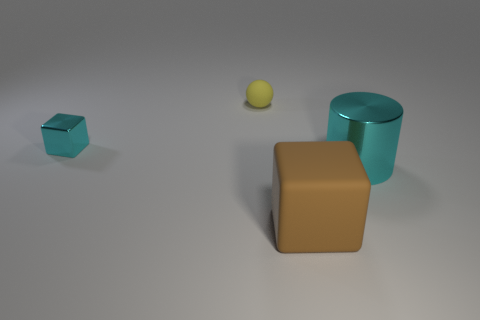The cyan metal thing that is the same size as the matte ball is what shape?
Keep it short and to the point. Cube. There is a small shiny thing; is its color the same as the tiny thing right of the small cyan metallic cube?
Offer a very short reply. No. How many things are either cyan metallic objects that are behind the large shiny object or things that are behind the cyan cube?
Make the answer very short. 2. What is the material of the cyan cylinder that is the same size as the brown object?
Offer a terse response. Metal. How many other objects are the same material as the cyan block?
Offer a terse response. 1. Does the cyan thing in front of the cyan metallic cube have the same shape as the rubber object that is in front of the large metal thing?
Offer a very short reply. No. What color is the metallic thing right of the thing behind the cyan thing behind the large cyan cylinder?
Offer a very short reply. Cyan. How many other things are the same color as the large cylinder?
Your answer should be very brief. 1. Is the number of small objects less than the number of things?
Provide a short and direct response. Yes. What color is the object that is both behind the big brown object and in front of the metal cube?
Your response must be concise. Cyan. 